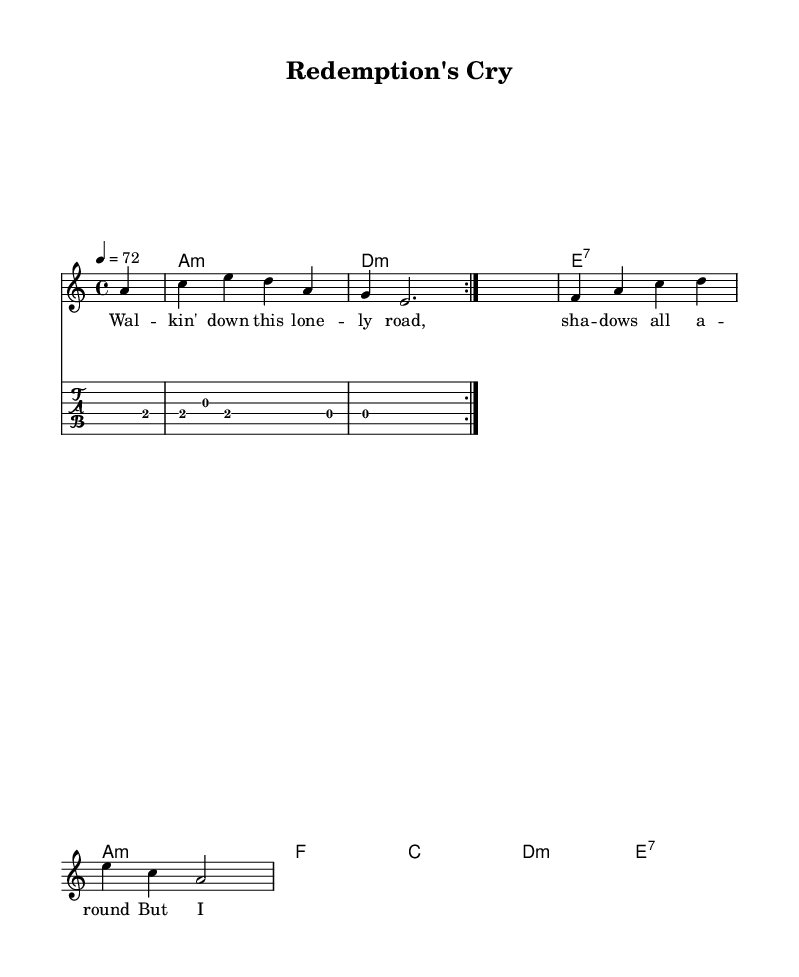What is the key signature of this piece? The key signature displayed in the sheet music indicates one flat (the B flat), which corresponds to the key of A minor (relative to C major). It is determined by looking at the beginning of the staff where the key signature is indicated.
Answer: A minor What is the time signature of this composition? The time signature is shown as 4/4 at the beginning of the staff. This indicates that there are four beats in each measure and the quarter note gets one beat. This can be confirmed by examining the notation at the beginning of the piece.
Answer: 4/4 What is the tempo marking for this piece? The tempo marking is indicated by the text "4 = 72," which means the piece should be played at a speed of 72 beats per minute, with each beat corresponding to a quarter note. This is found in the tempo directive at the start of the score.
Answer: 72 Which chords are used in the verse section? The chords in the verse are A minor, D minor, E major 7, and A minor. These can be identified by looking at the chord symbols placed above the staff during the verse.
Answer: A minor, D minor, E major 7, A minor What lyrical theme is suggested in the lyrics? The lyrics suggest themes of loneliness and hope, found in phrases like "walking down this lonely road" and "I hear that gospel sound." Such analysis comes from reading the text aligned with the melody, which often reflects emotional expression typical in electric blues.
Answer: Loneliness and hope How many measures are presented in the guitar riff? The guitar riff repeats over a total of four measures, as each volta (or repeated section) shows the same two measures repeated twice. This is confirmed by counting the measures outlined in the guitar part.
Answer: Four measures What characterizes the vocal style in this electric blues piece? The vocal style is characterized by a soulful delivery influenced by gospel sing, characterized by expressive phrasing and emotional intensity, reflecting the blues tradition. This inference is drawn from the lyrical content and the typical stylistic elements present in electric blues music.
Answer: Soulful and gospel-influenced 